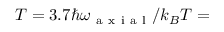Convert formula to latex. <formula><loc_0><loc_0><loc_500><loc_500>T = 3 . 7 \hbar { \omega } _ { a x i a l } / k _ { B } T =</formula> 